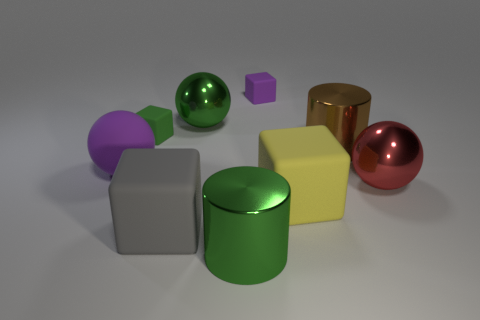What is the material of the green cylinder that is the same size as the brown object?
Your answer should be compact. Metal. Is there a big brown cylinder made of the same material as the tiny purple thing?
Give a very brief answer. No. Is the number of large gray matte objects that are right of the large green metallic cylinder less than the number of brown cylinders?
Offer a very short reply. Yes. What material is the cylinder that is in front of the big object that is on the left side of the tiny green block?
Make the answer very short. Metal. The large matte object that is behind the large gray thing and to the left of the yellow matte cube has what shape?
Your answer should be very brief. Sphere. What number of other things are the same color as the matte sphere?
Your response must be concise. 1. How many objects are large metallic objects in front of the yellow matte cube or tiny blocks?
Your answer should be compact. 3. There is a big rubber ball; is its color the same as the matte thing that is behind the green cube?
Keep it short and to the point. Yes. Are there any other things that have the same size as the red object?
Give a very brief answer. Yes. There is a shiny sphere that is behind the large cylinder that is behind the yellow block; how big is it?
Your answer should be very brief. Large. 